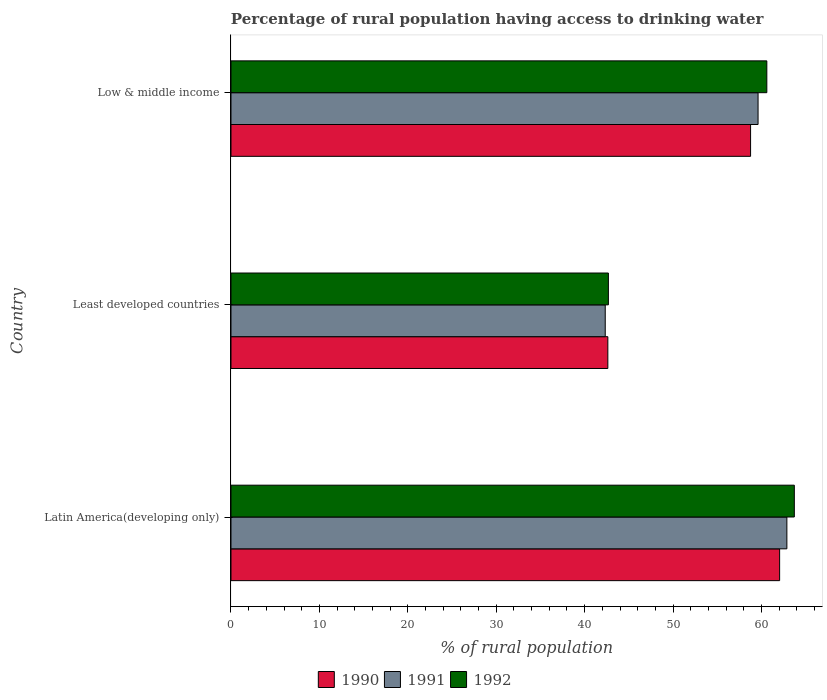How many groups of bars are there?
Make the answer very short. 3. What is the label of the 2nd group of bars from the top?
Offer a very short reply. Least developed countries. What is the percentage of rural population having access to drinking water in 1990 in Least developed countries?
Make the answer very short. 42.62. Across all countries, what is the maximum percentage of rural population having access to drinking water in 1992?
Offer a terse response. 63.71. Across all countries, what is the minimum percentage of rural population having access to drinking water in 1990?
Offer a very short reply. 42.62. In which country was the percentage of rural population having access to drinking water in 1990 maximum?
Offer a terse response. Latin America(developing only). In which country was the percentage of rural population having access to drinking water in 1991 minimum?
Offer a very short reply. Least developed countries. What is the total percentage of rural population having access to drinking water in 1991 in the graph?
Offer a terse response. 164.81. What is the difference between the percentage of rural population having access to drinking water in 1991 in Latin America(developing only) and that in Low & middle income?
Ensure brevity in your answer.  3.26. What is the difference between the percentage of rural population having access to drinking water in 1991 in Latin America(developing only) and the percentage of rural population having access to drinking water in 1990 in Low & middle income?
Provide a succinct answer. 4.11. What is the average percentage of rural population having access to drinking water in 1991 per country?
Your response must be concise. 54.94. What is the difference between the percentage of rural population having access to drinking water in 1992 and percentage of rural population having access to drinking water in 1990 in Least developed countries?
Keep it short and to the point. 0.06. In how many countries, is the percentage of rural population having access to drinking water in 1990 greater than 24 %?
Offer a terse response. 3. What is the ratio of the percentage of rural population having access to drinking water in 1991 in Latin America(developing only) to that in Least developed countries?
Keep it short and to the point. 1.49. What is the difference between the highest and the second highest percentage of rural population having access to drinking water in 1991?
Offer a very short reply. 3.26. What is the difference between the highest and the lowest percentage of rural population having access to drinking water in 1990?
Your response must be concise. 19.43. In how many countries, is the percentage of rural population having access to drinking water in 1992 greater than the average percentage of rural population having access to drinking water in 1992 taken over all countries?
Your response must be concise. 2. Is the sum of the percentage of rural population having access to drinking water in 1991 in Latin America(developing only) and Low & middle income greater than the maximum percentage of rural population having access to drinking water in 1990 across all countries?
Your answer should be compact. Yes. How many countries are there in the graph?
Give a very brief answer. 3. Are the values on the major ticks of X-axis written in scientific E-notation?
Your answer should be very brief. No. Does the graph contain any zero values?
Provide a succinct answer. No. Does the graph contain grids?
Offer a very short reply. No. How many legend labels are there?
Offer a very short reply. 3. How are the legend labels stacked?
Give a very brief answer. Horizontal. What is the title of the graph?
Your answer should be very brief. Percentage of rural population having access to drinking water. Does "1977" appear as one of the legend labels in the graph?
Your answer should be compact. No. What is the label or title of the X-axis?
Your answer should be compact. % of rural population. What is the label or title of the Y-axis?
Your response must be concise. Country. What is the % of rural population in 1990 in Latin America(developing only)?
Ensure brevity in your answer.  62.05. What is the % of rural population in 1991 in Latin America(developing only)?
Your answer should be very brief. 62.87. What is the % of rural population in 1992 in Latin America(developing only)?
Provide a short and direct response. 63.71. What is the % of rural population in 1990 in Least developed countries?
Provide a succinct answer. 42.62. What is the % of rural population of 1991 in Least developed countries?
Offer a terse response. 42.33. What is the % of rural population of 1992 in Least developed countries?
Provide a short and direct response. 42.68. What is the % of rural population in 1990 in Low & middle income?
Keep it short and to the point. 58.76. What is the % of rural population in 1991 in Low & middle income?
Your response must be concise. 59.61. What is the % of rural population in 1992 in Low & middle income?
Your answer should be very brief. 60.6. Across all countries, what is the maximum % of rural population of 1990?
Offer a terse response. 62.05. Across all countries, what is the maximum % of rural population in 1991?
Keep it short and to the point. 62.87. Across all countries, what is the maximum % of rural population of 1992?
Your answer should be compact. 63.71. Across all countries, what is the minimum % of rural population of 1990?
Keep it short and to the point. 42.62. Across all countries, what is the minimum % of rural population in 1991?
Your answer should be very brief. 42.33. Across all countries, what is the minimum % of rural population of 1992?
Your answer should be very brief. 42.68. What is the total % of rural population of 1990 in the graph?
Your response must be concise. 163.44. What is the total % of rural population in 1991 in the graph?
Provide a succinct answer. 164.81. What is the total % of rural population in 1992 in the graph?
Your answer should be compact. 167. What is the difference between the % of rural population in 1990 in Latin America(developing only) and that in Least developed countries?
Offer a very short reply. 19.43. What is the difference between the % of rural population of 1991 in Latin America(developing only) and that in Least developed countries?
Your response must be concise. 20.54. What is the difference between the % of rural population of 1992 in Latin America(developing only) and that in Least developed countries?
Offer a very short reply. 21.03. What is the difference between the % of rural population in 1990 in Latin America(developing only) and that in Low & middle income?
Your response must be concise. 3.29. What is the difference between the % of rural population in 1991 in Latin America(developing only) and that in Low & middle income?
Ensure brevity in your answer.  3.26. What is the difference between the % of rural population of 1992 in Latin America(developing only) and that in Low & middle income?
Offer a terse response. 3.11. What is the difference between the % of rural population in 1990 in Least developed countries and that in Low & middle income?
Provide a short and direct response. -16.14. What is the difference between the % of rural population of 1991 in Least developed countries and that in Low & middle income?
Your answer should be compact. -17.29. What is the difference between the % of rural population in 1992 in Least developed countries and that in Low & middle income?
Keep it short and to the point. -17.92. What is the difference between the % of rural population in 1990 in Latin America(developing only) and the % of rural population in 1991 in Least developed countries?
Your response must be concise. 19.72. What is the difference between the % of rural population of 1990 in Latin America(developing only) and the % of rural population of 1992 in Least developed countries?
Keep it short and to the point. 19.37. What is the difference between the % of rural population of 1991 in Latin America(developing only) and the % of rural population of 1992 in Least developed countries?
Provide a short and direct response. 20.19. What is the difference between the % of rural population of 1990 in Latin America(developing only) and the % of rural population of 1991 in Low & middle income?
Make the answer very short. 2.44. What is the difference between the % of rural population of 1990 in Latin America(developing only) and the % of rural population of 1992 in Low & middle income?
Offer a very short reply. 1.45. What is the difference between the % of rural population of 1991 in Latin America(developing only) and the % of rural population of 1992 in Low & middle income?
Give a very brief answer. 2.27. What is the difference between the % of rural population in 1990 in Least developed countries and the % of rural population in 1991 in Low & middle income?
Provide a short and direct response. -16.99. What is the difference between the % of rural population of 1990 in Least developed countries and the % of rural population of 1992 in Low & middle income?
Give a very brief answer. -17.98. What is the difference between the % of rural population in 1991 in Least developed countries and the % of rural population in 1992 in Low & middle income?
Provide a succinct answer. -18.28. What is the average % of rural population in 1990 per country?
Provide a short and direct response. 54.48. What is the average % of rural population of 1991 per country?
Your answer should be compact. 54.94. What is the average % of rural population of 1992 per country?
Keep it short and to the point. 55.67. What is the difference between the % of rural population in 1990 and % of rural population in 1991 in Latin America(developing only)?
Give a very brief answer. -0.82. What is the difference between the % of rural population in 1990 and % of rural population in 1992 in Latin America(developing only)?
Make the answer very short. -1.66. What is the difference between the % of rural population in 1991 and % of rural population in 1992 in Latin America(developing only)?
Keep it short and to the point. -0.84. What is the difference between the % of rural population of 1990 and % of rural population of 1991 in Least developed countries?
Provide a succinct answer. 0.29. What is the difference between the % of rural population in 1990 and % of rural population in 1992 in Least developed countries?
Offer a terse response. -0.06. What is the difference between the % of rural population of 1991 and % of rural population of 1992 in Least developed countries?
Offer a very short reply. -0.36. What is the difference between the % of rural population of 1990 and % of rural population of 1991 in Low & middle income?
Give a very brief answer. -0.85. What is the difference between the % of rural population in 1990 and % of rural population in 1992 in Low & middle income?
Make the answer very short. -1.84. What is the difference between the % of rural population in 1991 and % of rural population in 1992 in Low & middle income?
Offer a terse response. -0.99. What is the ratio of the % of rural population in 1990 in Latin America(developing only) to that in Least developed countries?
Your answer should be very brief. 1.46. What is the ratio of the % of rural population in 1991 in Latin America(developing only) to that in Least developed countries?
Your answer should be compact. 1.49. What is the ratio of the % of rural population of 1992 in Latin America(developing only) to that in Least developed countries?
Your response must be concise. 1.49. What is the ratio of the % of rural population of 1990 in Latin America(developing only) to that in Low & middle income?
Your answer should be compact. 1.06. What is the ratio of the % of rural population in 1991 in Latin America(developing only) to that in Low & middle income?
Provide a short and direct response. 1.05. What is the ratio of the % of rural population of 1992 in Latin America(developing only) to that in Low & middle income?
Your answer should be very brief. 1.05. What is the ratio of the % of rural population in 1990 in Least developed countries to that in Low & middle income?
Offer a terse response. 0.73. What is the ratio of the % of rural population in 1991 in Least developed countries to that in Low & middle income?
Your answer should be very brief. 0.71. What is the ratio of the % of rural population of 1992 in Least developed countries to that in Low & middle income?
Your answer should be very brief. 0.7. What is the difference between the highest and the second highest % of rural population in 1990?
Your response must be concise. 3.29. What is the difference between the highest and the second highest % of rural population of 1991?
Keep it short and to the point. 3.26. What is the difference between the highest and the second highest % of rural population in 1992?
Keep it short and to the point. 3.11. What is the difference between the highest and the lowest % of rural population of 1990?
Make the answer very short. 19.43. What is the difference between the highest and the lowest % of rural population of 1991?
Your response must be concise. 20.54. What is the difference between the highest and the lowest % of rural population of 1992?
Give a very brief answer. 21.03. 